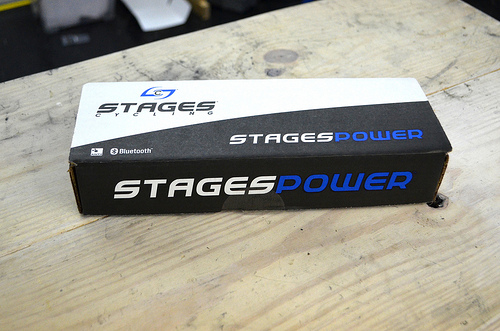<image>
Is the wood under the box? Yes. The wood is positioned underneath the box, with the box above it in the vertical space. 